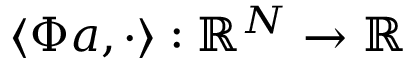Convert formula to latex. <formula><loc_0><loc_0><loc_500><loc_500>\left < \Phi a , \cdot \right > \colon \mathbb { R } ^ { N } \rightarrow \mathbb { R }</formula> 